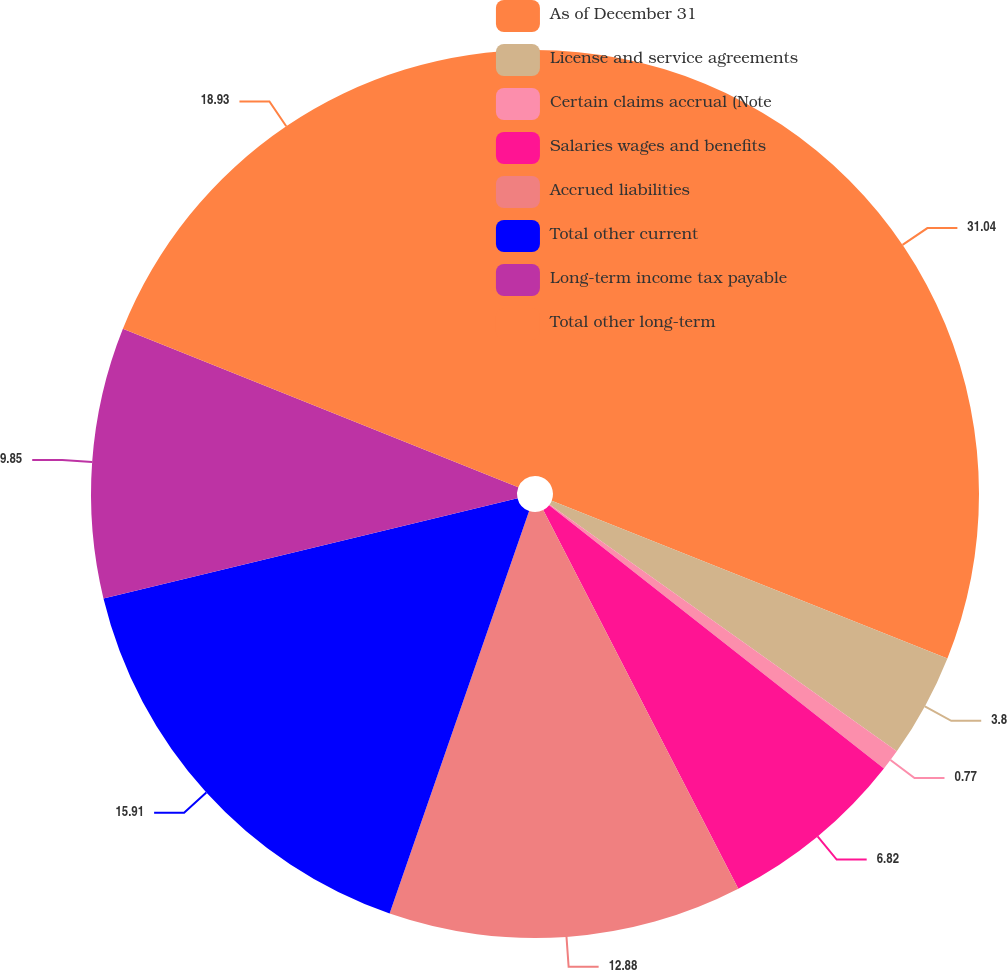Convert chart. <chart><loc_0><loc_0><loc_500><loc_500><pie_chart><fcel>As of December 31<fcel>License and service agreements<fcel>Certain claims accrual (Note<fcel>Salaries wages and benefits<fcel>Accrued liabilities<fcel>Total other current<fcel>Long-term income tax payable<fcel>Total other long-term<nl><fcel>31.04%<fcel>3.8%<fcel>0.77%<fcel>6.82%<fcel>12.88%<fcel>15.91%<fcel>9.85%<fcel>18.93%<nl></chart> 